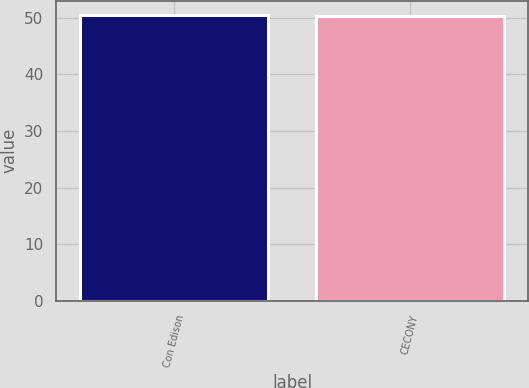Convert chart to OTSL. <chart><loc_0><loc_0><loc_500><loc_500><bar_chart><fcel>Con Edison<fcel>CECONY<nl><fcel>50.5<fcel>50.3<nl></chart> 